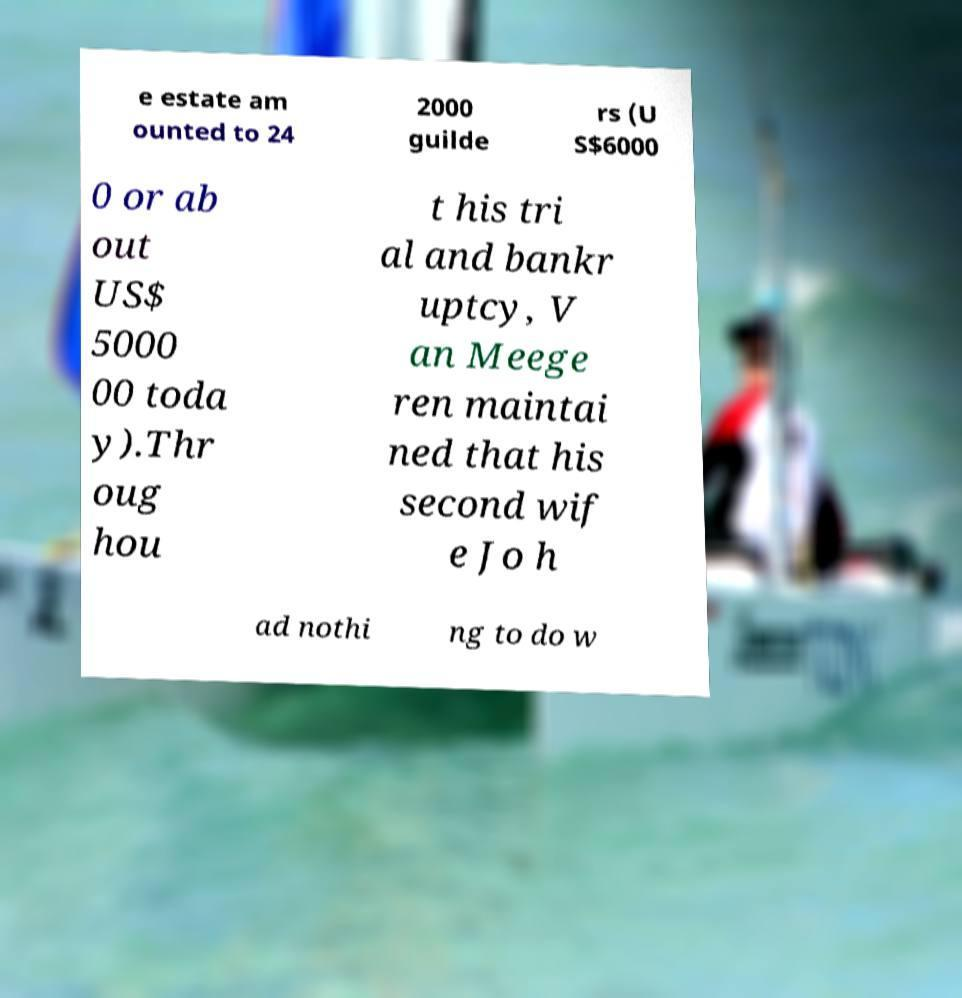There's text embedded in this image that I need extracted. Can you transcribe it verbatim? e estate am ounted to 24 2000 guilde rs (U S$6000 0 or ab out US$ 5000 00 toda y).Thr oug hou t his tri al and bankr uptcy, V an Meege ren maintai ned that his second wif e Jo h ad nothi ng to do w 